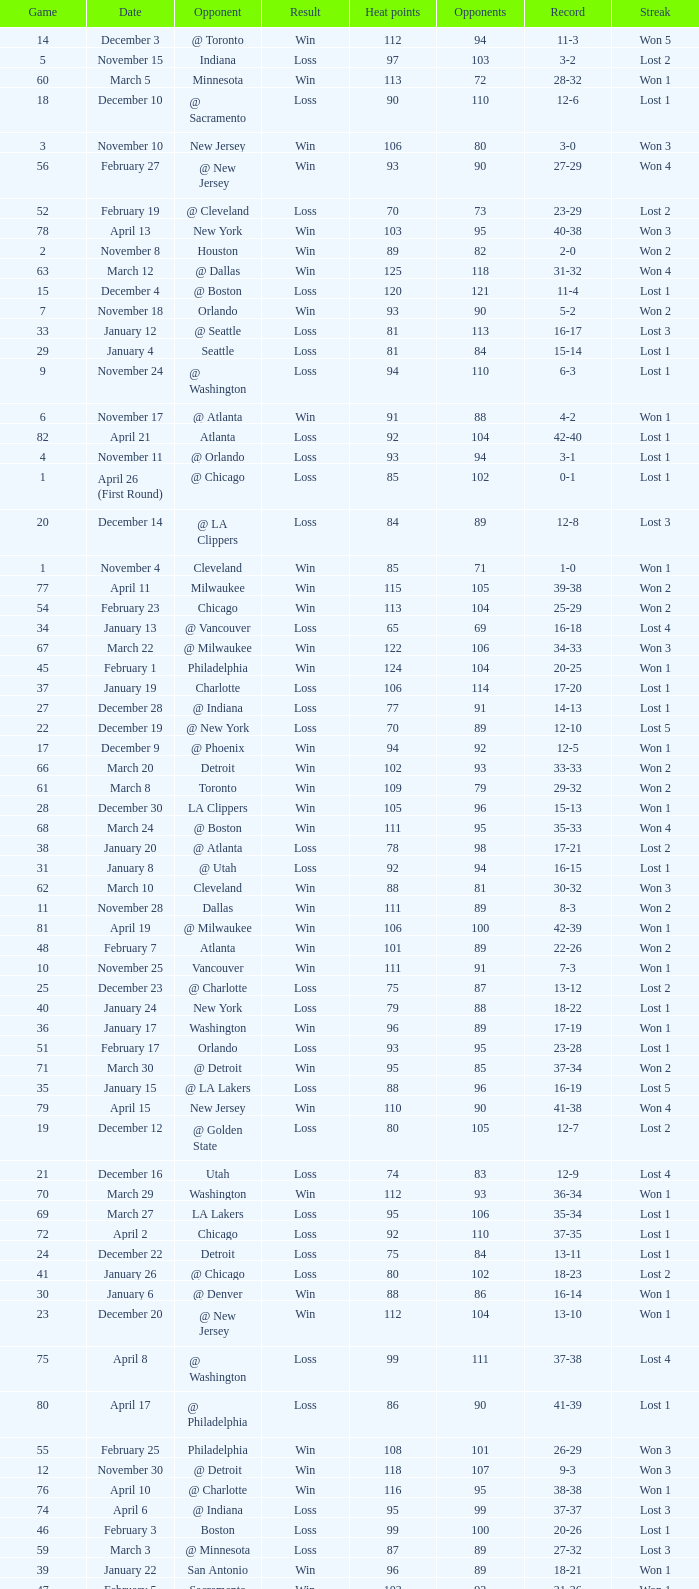What is the highest Game, when Opponents is less than 80, and when Record is "1-0"? 1.0. 